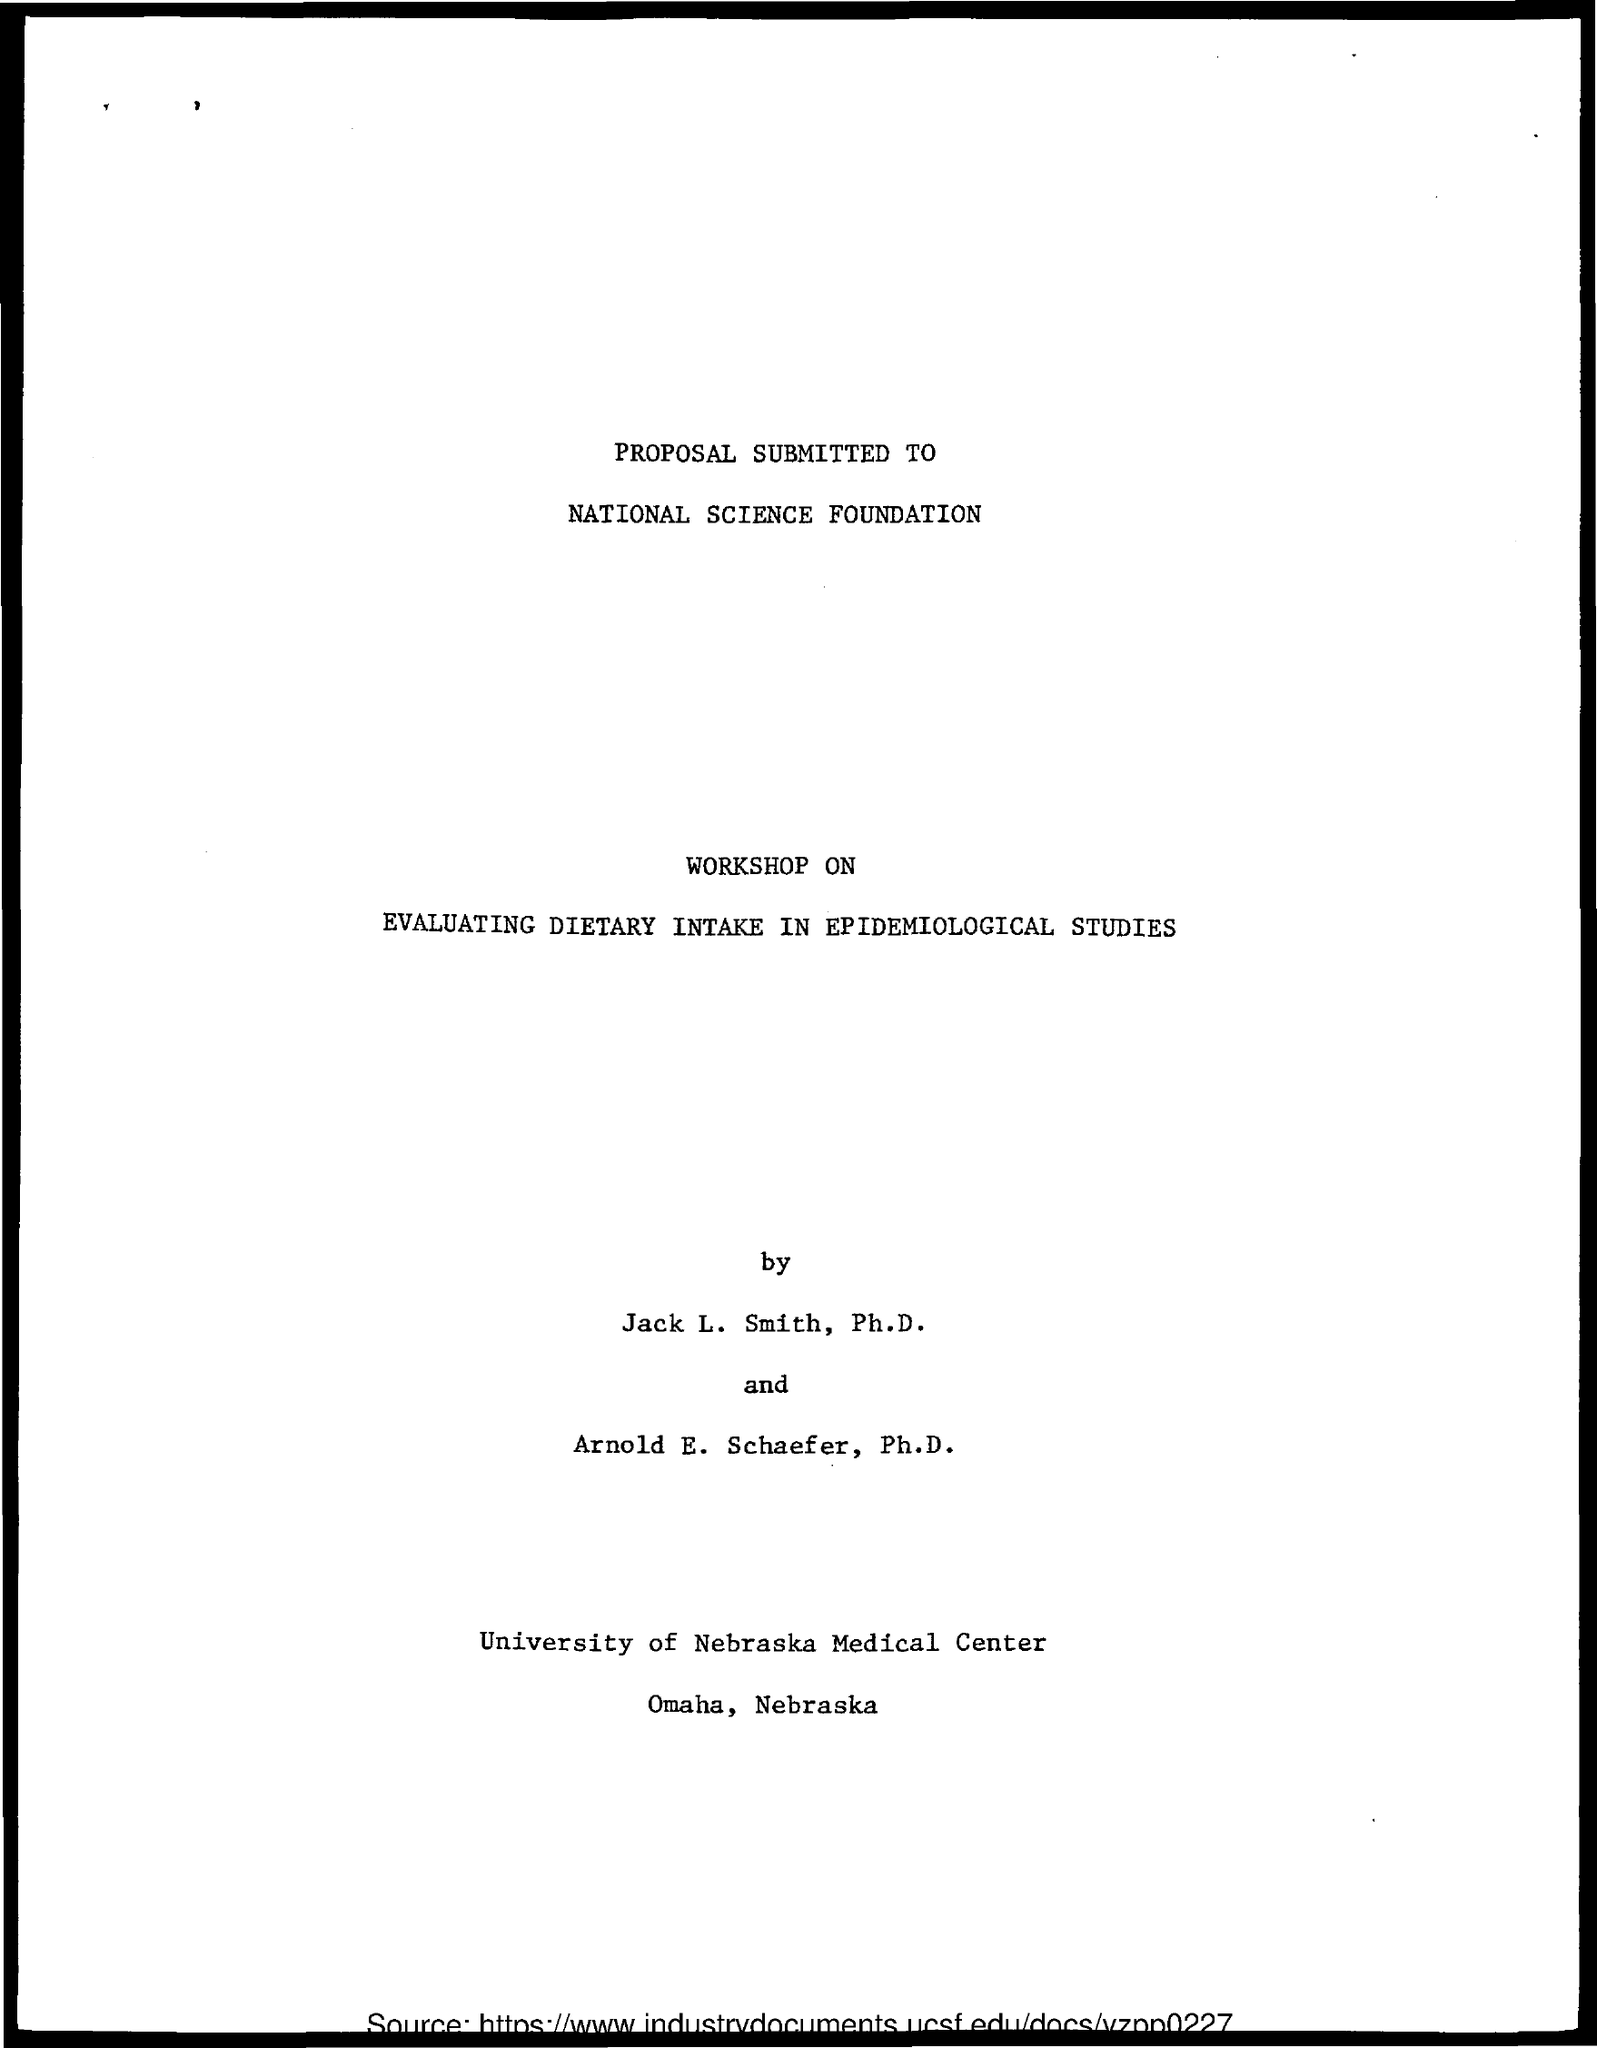Draw attention to some important aspects in this diagram. The workshop will focus on evaluating dietary intake in epidemiological studies. The National Science Foundation is a foundation that is commonly mentioned. 